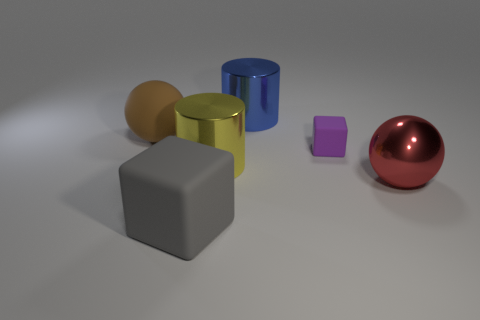Does the small cube have the same color as the large matte sphere?
Keep it short and to the point. No. Is there any other thing that is the same color as the tiny matte thing?
Your answer should be compact. No. Does the large matte object right of the matte sphere have the same shape as the large metallic object right of the blue shiny cylinder?
Offer a very short reply. No. What number of objects are blue metallic objects or blocks on the right side of the gray block?
Make the answer very short. 2. What number of other things are the same size as the red object?
Give a very brief answer. 4. Does the large ball that is right of the small cube have the same material as the cylinder that is behind the large brown object?
Provide a short and direct response. Yes. What number of big red metal balls are on the right side of the purple rubber thing?
Make the answer very short. 1. How many red objects are either large matte things or large objects?
Provide a succinct answer. 1. What is the material of the yellow object that is the same size as the brown rubber ball?
Offer a terse response. Metal. There is a metal object that is both in front of the blue shiny thing and on the left side of the small rubber block; what is its shape?
Keep it short and to the point. Cylinder. 